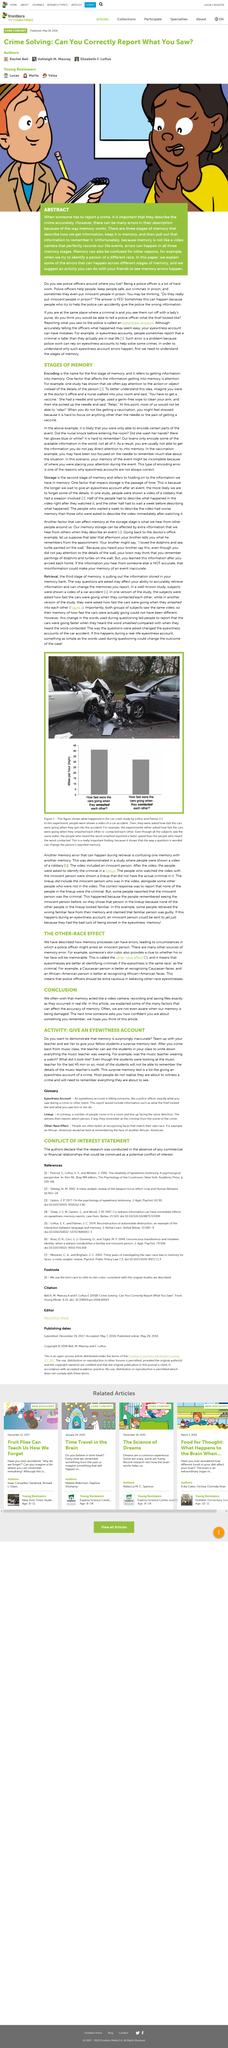Outline some significant characteristics in this image. The best race for recognizing Caucasian faces is Caucasians. The first stage of memory is known as encoding, which involves the conversion of sensory information into a form that can be stored and later retrieved. People often pay more attention to the actions or objects in an event rather than the details of a person. It is suggested that you engage in an activity with your friends to understand how memory errors occur. Giving an eyewitness account is similar to taking a surprise memory test. 